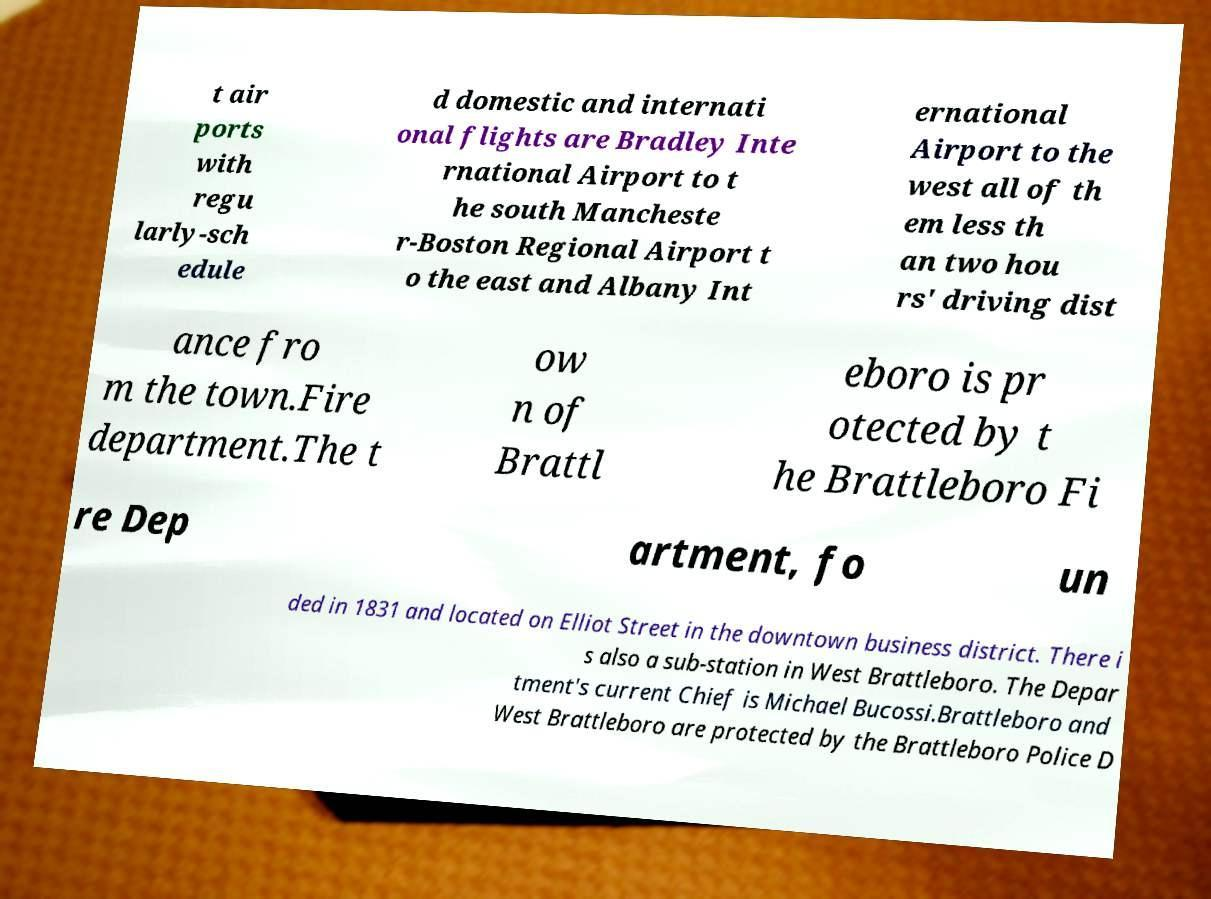Could you extract and type out the text from this image? t air ports with regu larly-sch edule d domestic and internati onal flights are Bradley Inte rnational Airport to t he south Mancheste r-Boston Regional Airport t o the east and Albany Int ernational Airport to the west all of th em less th an two hou rs' driving dist ance fro m the town.Fire department.The t ow n of Brattl eboro is pr otected by t he Brattleboro Fi re Dep artment, fo un ded in 1831 and located on Elliot Street in the downtown business district. There i s also a sub-station in West Brattleboro. The Depar tment's current Chief is Michael Bucossi.Brattleboro and West Brattleboro are protected by the Brattleboro Police D 